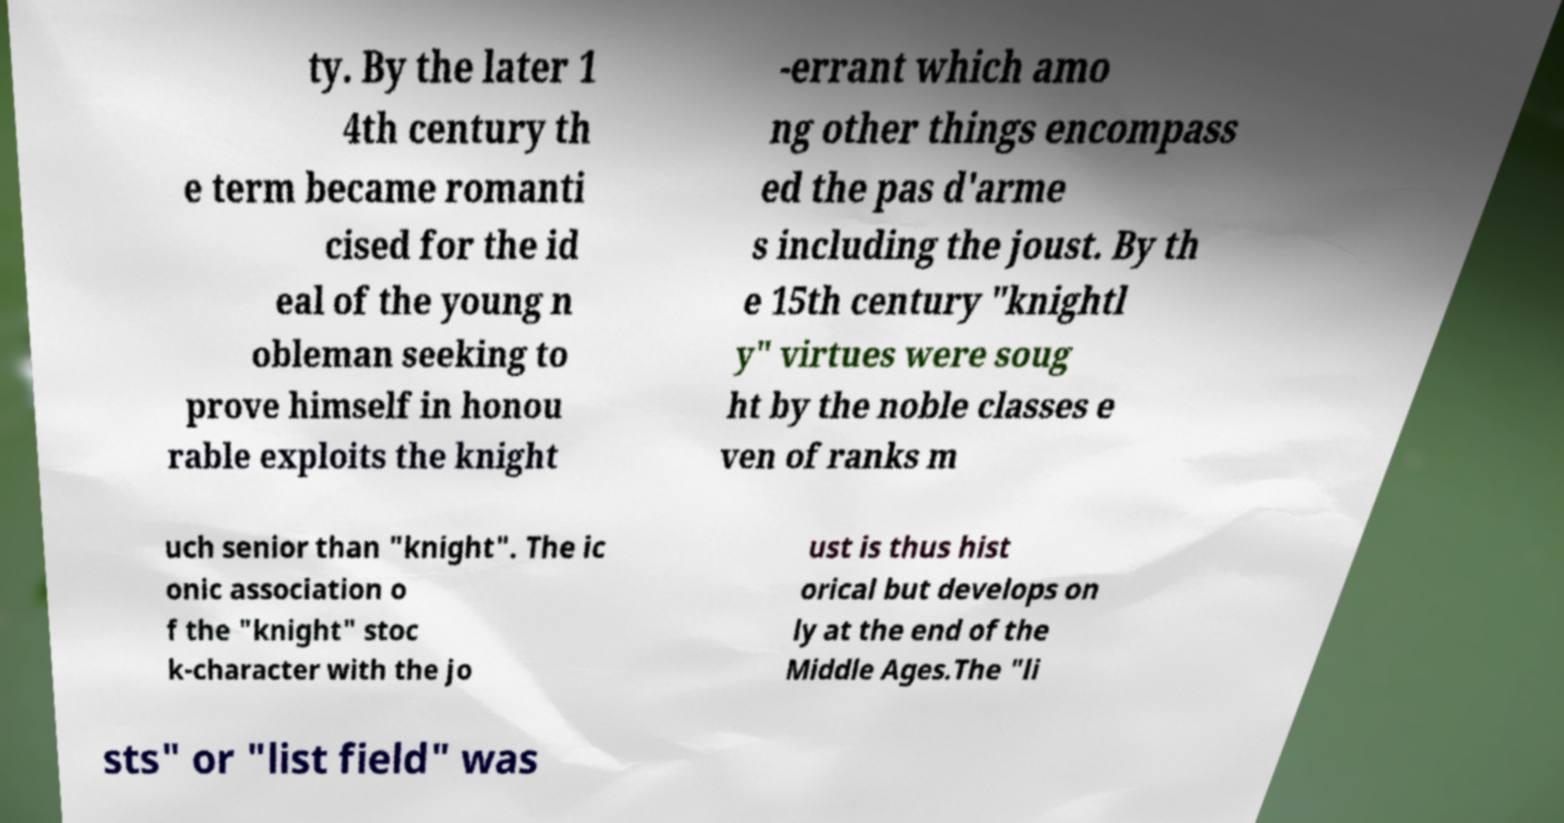Can you accurately transcribe the text from the provided image for me? ty. By the later 1 4th century th e term became romanti cised for the id eal of the young n obleman seeking to prove himself in honou rable exploits the knight -errant which amo ng other things encompass ed the pas d'arme s including the joust. By th e 15th century "knightl y" virtues were soug ht by the noble classes e ven of ranks m uch senior than "knight". The ic onic association o f the "knight" stoc k-character with the jo ust is thus hist orical but develops on ly at the end of the Middle Ages.The "li sts" or "list field" was 